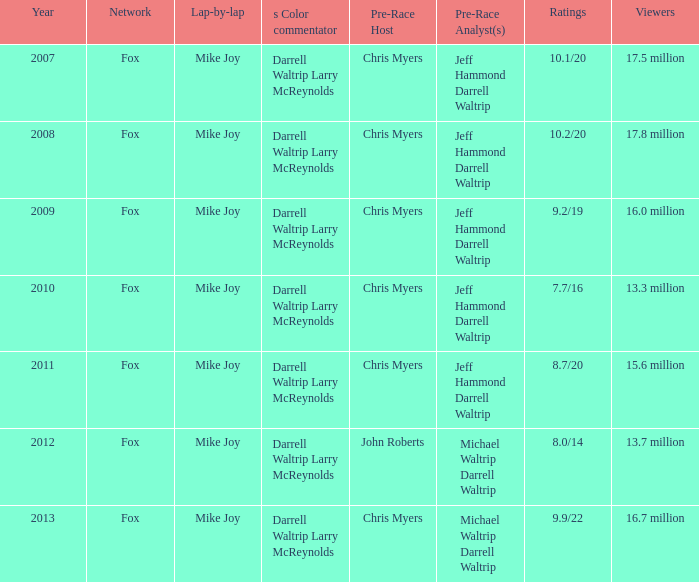In 2013, how many ratings were there? 9.9/22. 